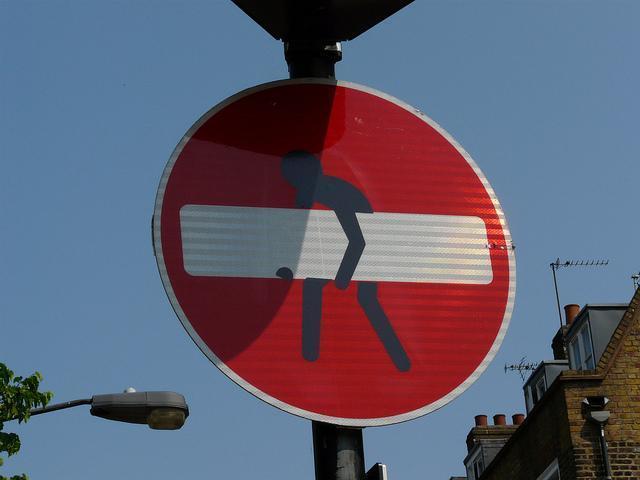How many clouds are in the sky?
Give a very brief answer. 0. 